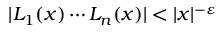Convert formula to latex. <formula><loc_0><loc_0><loc_500><loc_500>| L _ { 1 } ( x ) \cdots L _ { n } ( x ) | < | x | ^ { - \varepsilon }</formula> 